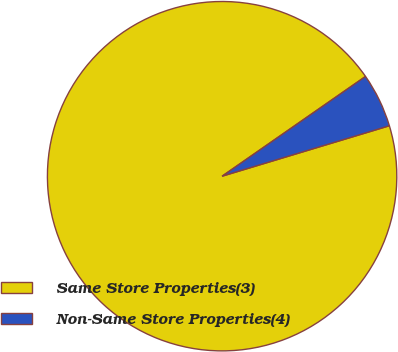Convert chart. <chart><loc_0><loc_0><loc_500><loc_500><pie_chart><fcel>Same Store Properties(3)<fcel>Non-Same Store Properties(4)<nl><fcel>94.99%<fcel>5.01%<nl></chart> 